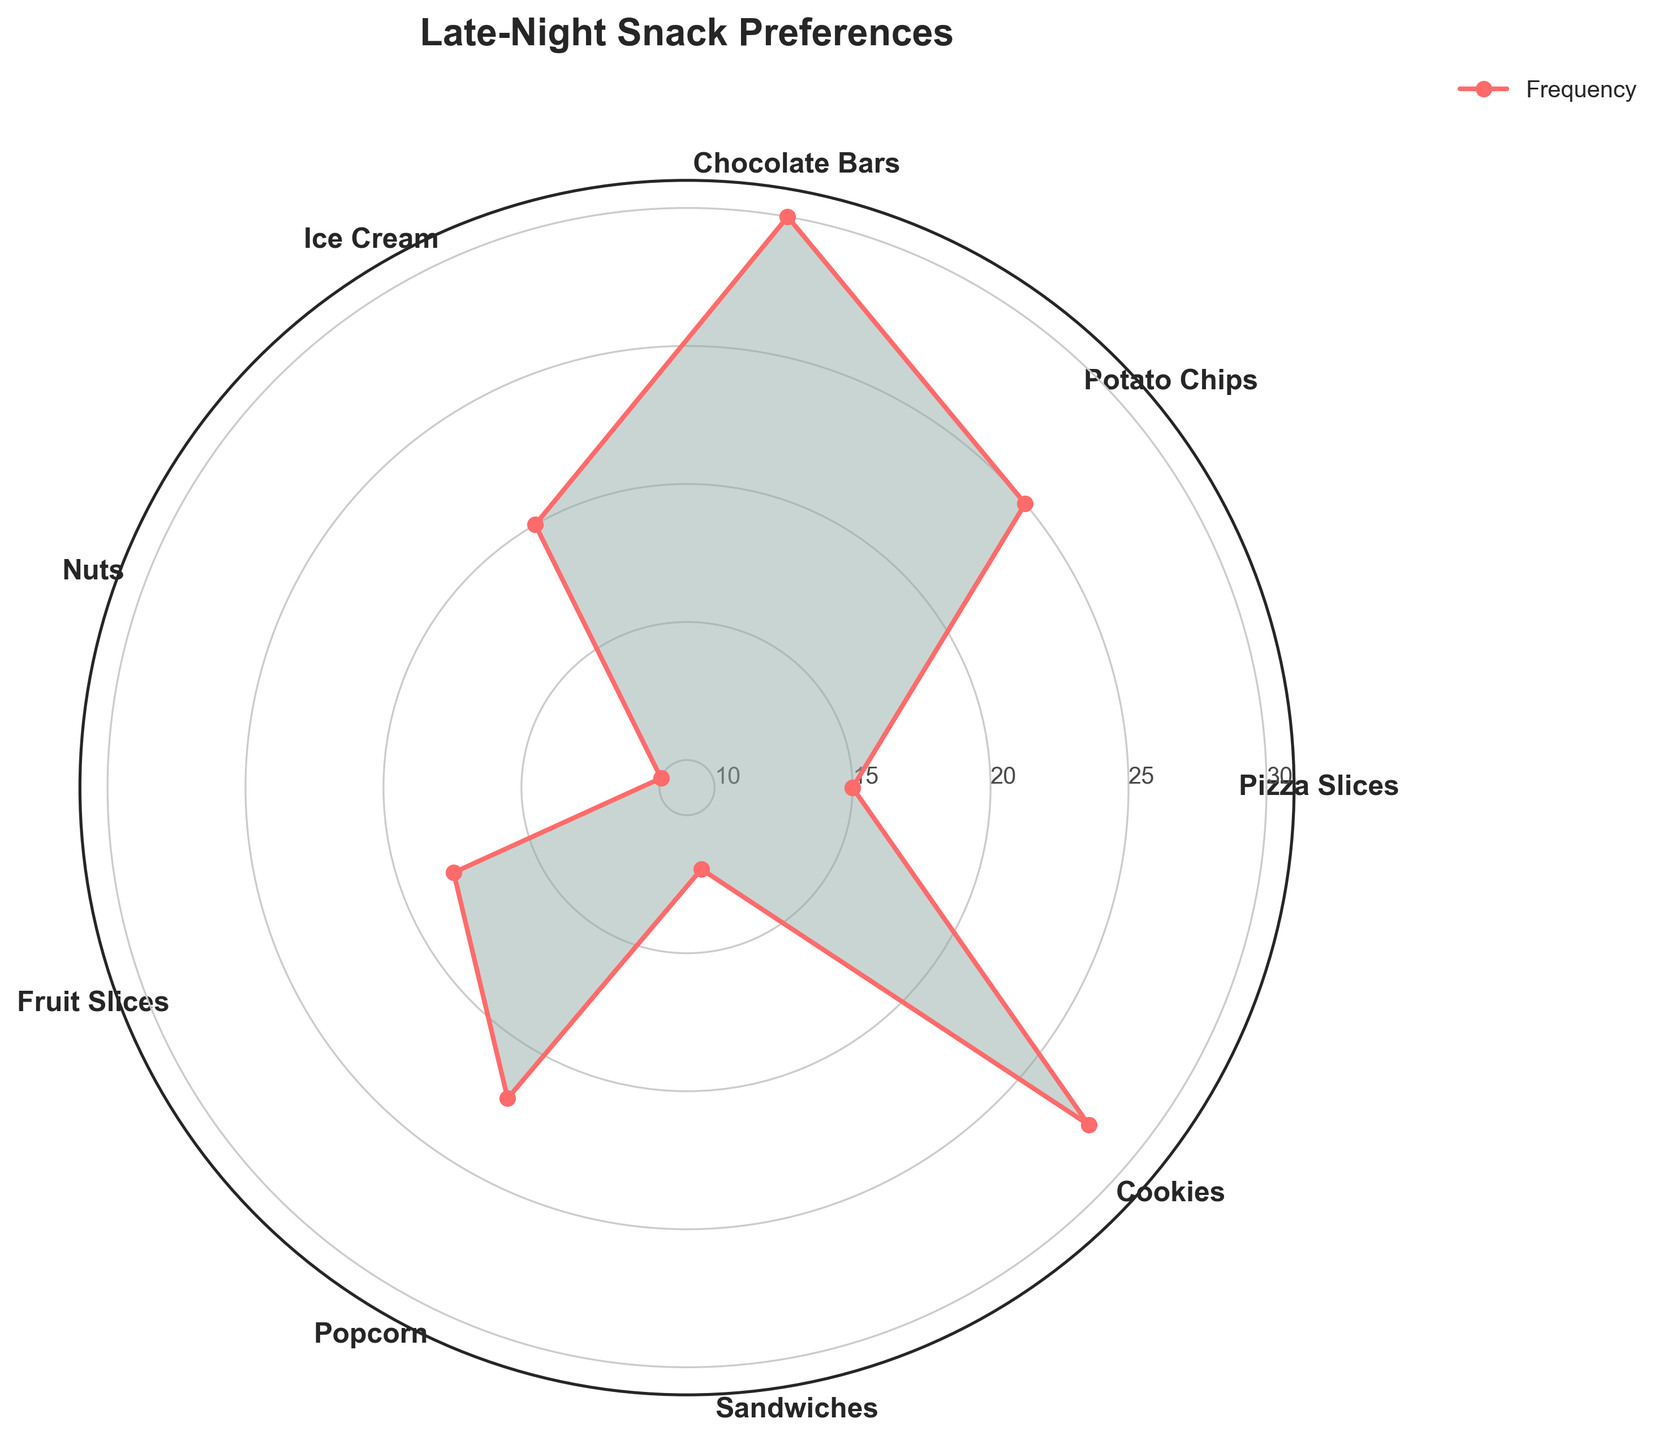What is the title of the chart? The title of the chart is displayed at the top of the figure, providing a clear summary of what the chart is about.
Answer: Late-Night Snack Preferences How many categories of snacks are displayed in the chart? The chart shows labels around the polar plot indicating different snack categories. By counting these, you can determine the number of categories.
Answer: Nine Which snack has the highest frequency of consumption? The frequency of each snack is indicated by how far each point extends from the center of the chart. The snack with the furthest point is the one with the highest frequency.
Answer: Chocolate Bars How many snacks have a frequency of 25 or more? By looking at the radial labels and comparing the extended points, count the number of snacks that meet or exceed the 25 mark.
Answer: Two What is the difference in consumption frequency between Ice Cream and Cookies? To find the difference, locate the points for both Ice Cream and Cookies and note their frequencies, then subtract the Ice Cream frequency from the Cookies frequency.
Answer: 8 What is the average frequency of consuming Pizza Slices, Fruit Slices, and Popcorn? First, note the frequencies of Pizza Slices (15), Fruit Slices (18), and Popcorn (22). Sum these values and divide by 3 to get the average.
Answer: (15 + 18 + 22) / 3 = 18.3 Which snack has a lower frequency of consumption, Sandwiches or Nuts? Check the frequencies indicated on the chart for both Sandwiches and Nuts. The snack with the lower frequency extends a shorter distance from the center.
Answer: Nuts Is the frequency of consuming Potato Chips greater than that of Sandwiches? Compare the points for Potato Chips and Sandwiches on the polar chart. The category with the further extension has a higher frequency.
Answer: Yes What is the total frequency of all snack categories combined? Sum the frequencies of all the snacks: Pizza Slices (15), Potato Chips (25), Chocolate Bars (30), Ice Cream (20), Nuts (10), Fruit Slices (18), Popcorn (22), Sandwiches (12), and Cookies (28).
Answer: 180 